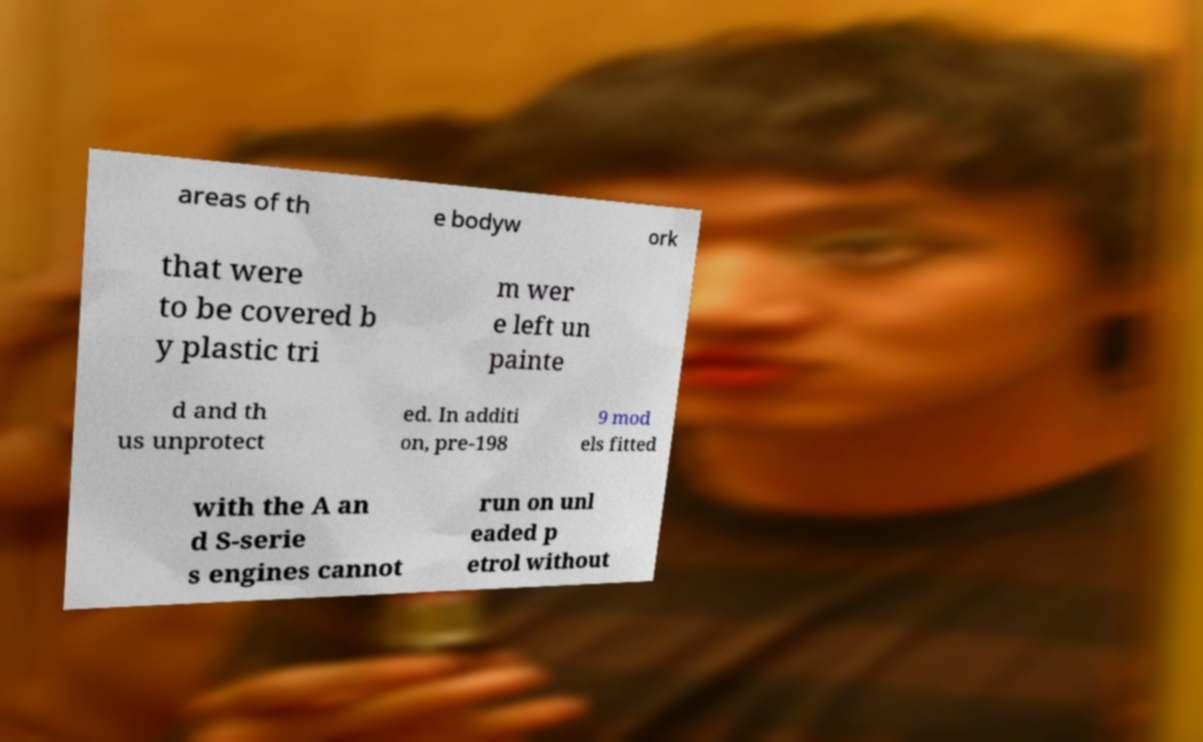Can you read and provide the text displayed in the image?This photo seems to have some interesting text. Can you extract and type it out for me? areas of th e bodyw ork that were to be covered b y plastic tri m wer e left un painte d and th us unprotect ed. In additi on, pre-198 9 mod els fitted with the A an d S-serie s engines cannot run on unl eaded p etrol without 